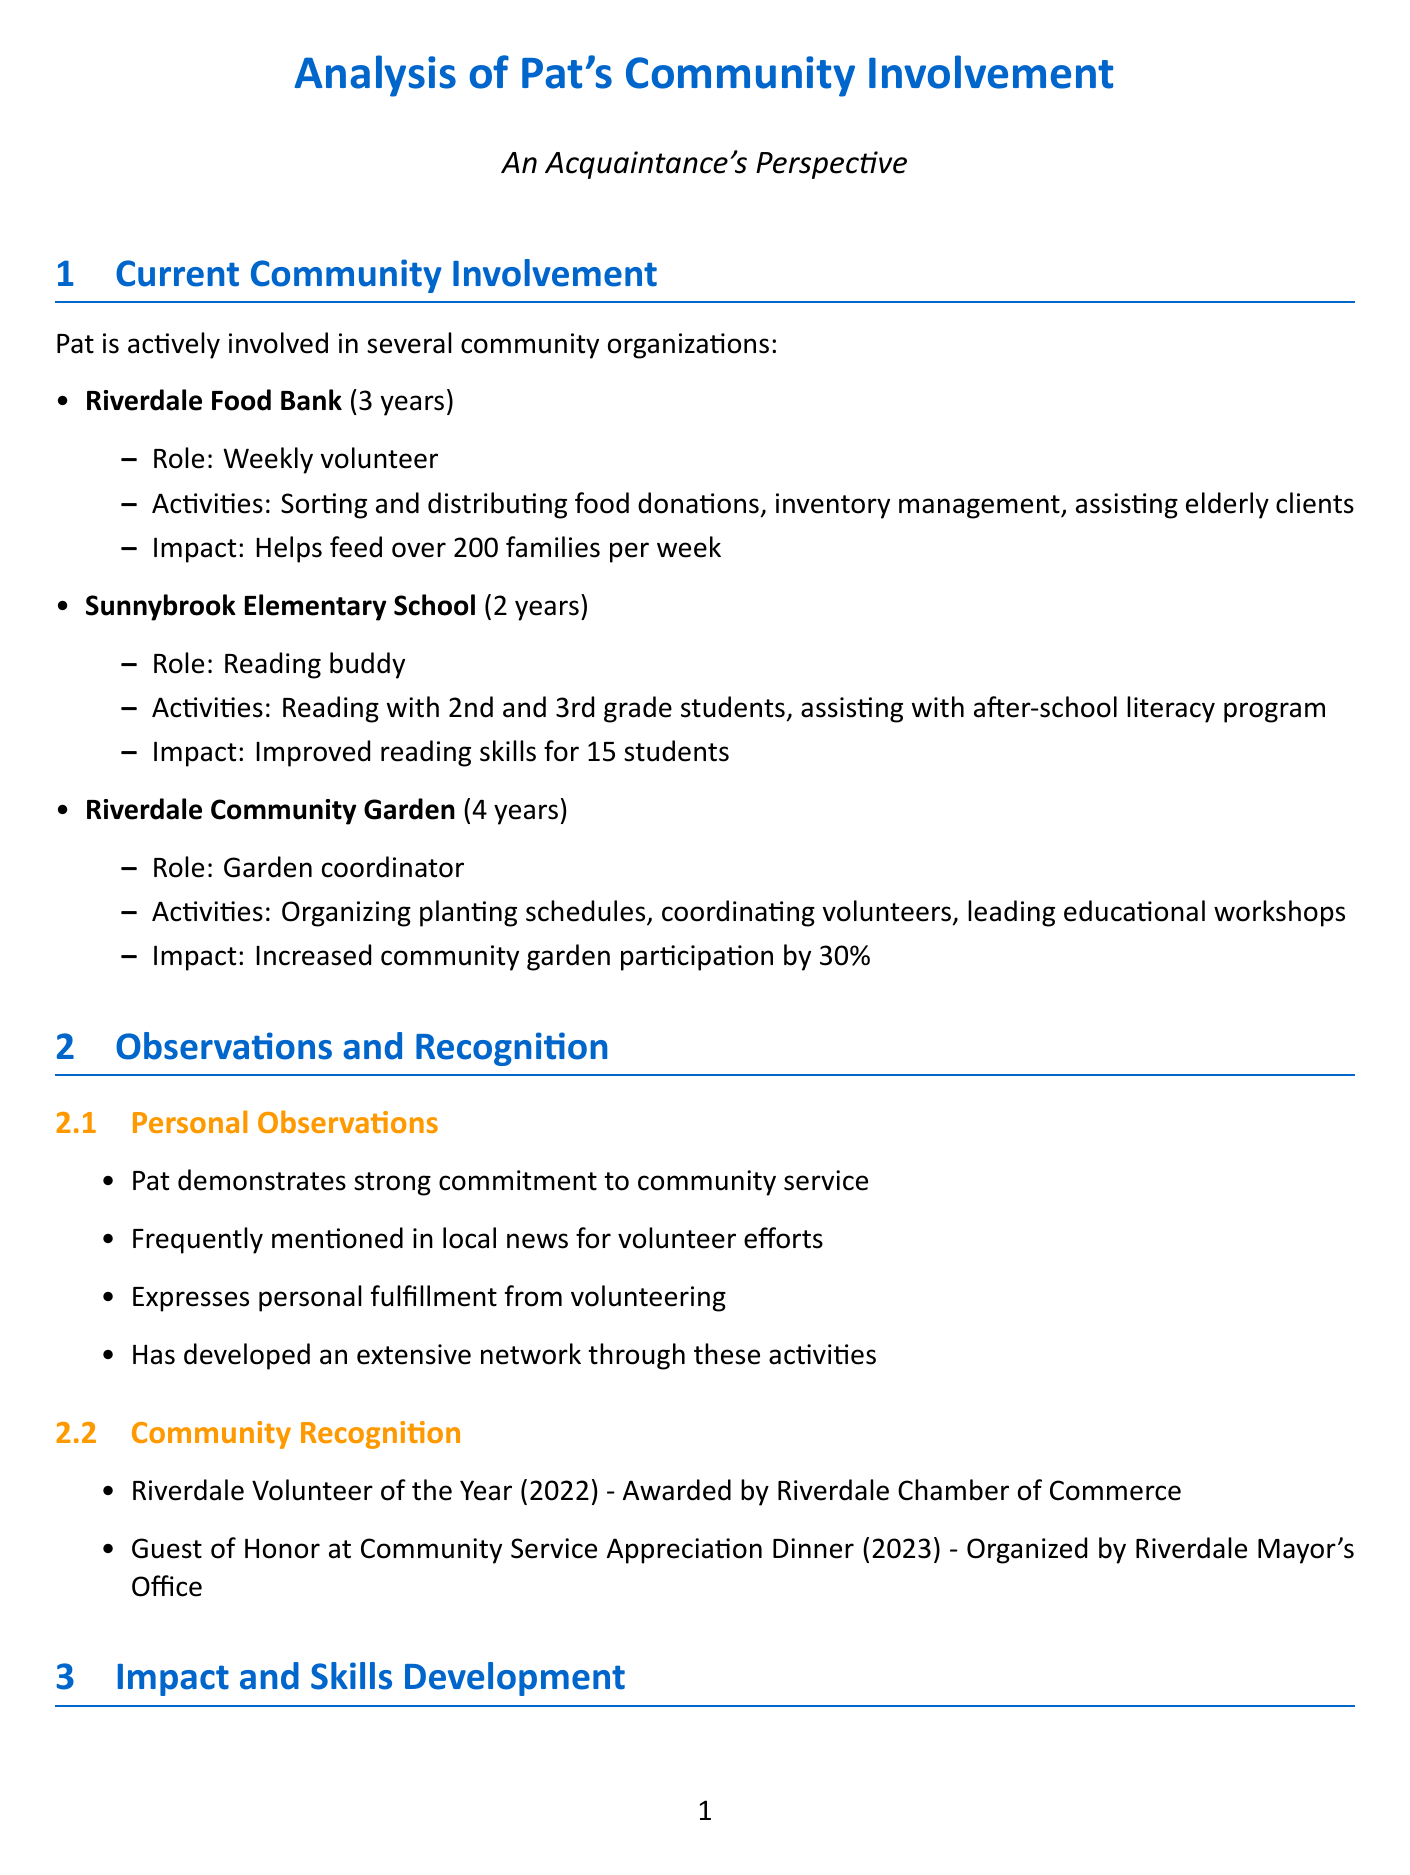what is Pat's role at the Riverdale Food Bank? Pat's role is a weekly volunteer at the Riverdale Food Bank.
Answer: Weekly volunteer how many families does the Riverdale Food Bank help feed each week? The document states that the Riverdale Food Bank helps feed over 200 families per week.
Answer: Over 200 families which award did Pat receive in 2022? Pat received the Riverdale Volunteer of the Year award in 2022.
Answer: Riverdale Volunteer of the Year how long has Pat been a garden coordinator at the Riverdale Community Garden? The duration of Pat's involvement as a garden coordinator is 4 years.
Answer: 4 years what is one of the skills developed by Pat through volunteering? The document lists several skills developed through volunteering, including project management.
Answer: Project management what is the motivation behind Pat's potential involvement with the Riverdale City Council? Pat's motivation for considering running for a seat is to have a broader impact on community development.
Answer: To have a broader impact on community development how many students did Pat help improve reading skills as a reading buddy? The document states that Pat helped improve reading skills for 15 students at Sunnybrook Elementary School.
Answer: 15 students what family involvement is mentioned in Pat's volunteer activities? It mentions that Pat's partner and children also participate in some volunteer activities.
Answer: Family participation in volunteer activities 